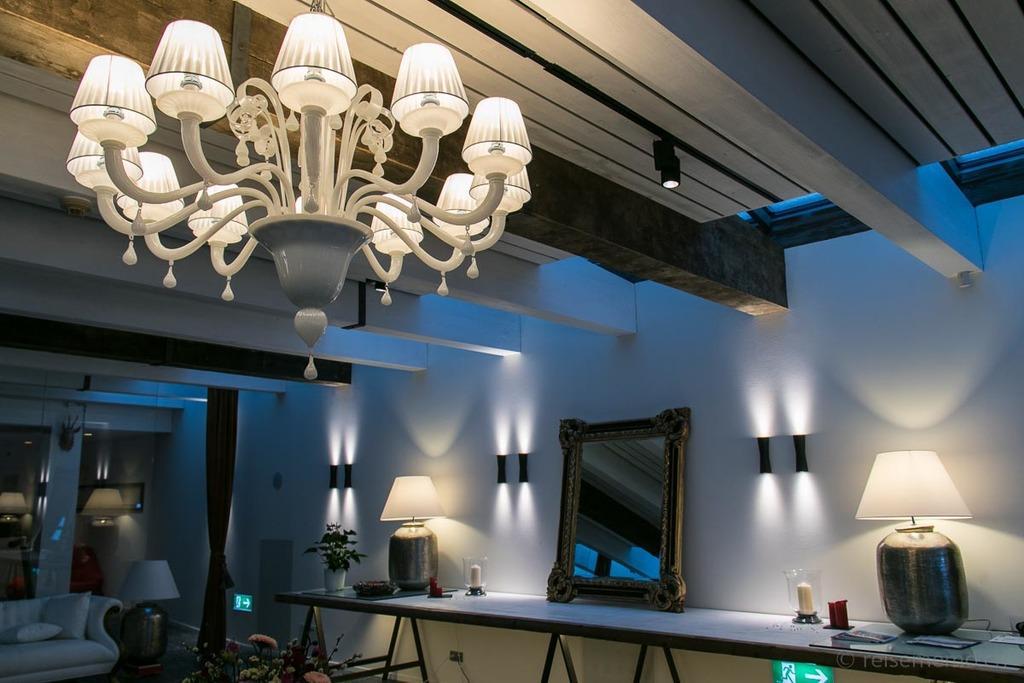How would you summarize this image in a sentence or two? In this image we can see plants in pot, candles, a mirror, lamps and some books placed on the table. On the left side of the image we can see some flowers, sofa and curtains. In the background, we can see some lights on the wall. At the top of the image we can see a chandelier. 